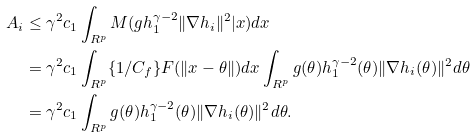<formula> <loc_0><loc_0><loc_500><loc_500>A _ { i } & \leq \gamma ^ { 2 } c _ { 1 } \int _ { R ^ { p } } M ( g h _ { 1 } ^ { \gamma - 2 } \| \nabla h _ { i } \| ^ { 2 } | x ) d x \\ & = \gamma ^ { 2 } c _ { 1 } \int _ { R ^ { p } } \{ 1 / C _ { f } \} F ( \| x - \theta \| ) d x \int _ { R ^ { p } } g ( \theta ) h _ { 1 } ^ { \gamma - 2 } ( \theta ) \| \nabla h _ { i } ( \theta ) \| ^ { 2 } d \theta \\ & = \gamma ^ { 2 } c _ { 1 } \int _ { R ^ { p } } g ( \theta ) h _ { 1 } ^ { \gamma - 2 } ( \theta ) \| \nabla h _ { i } ( \theta ) \| ^ { 2 } d \theta .</formula> 